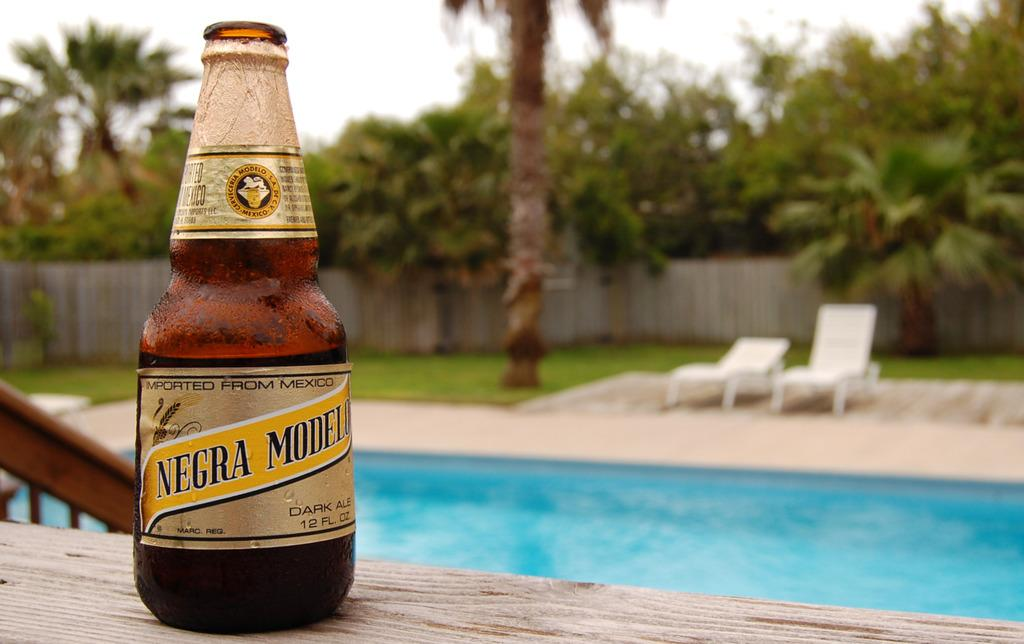<image>
Write a terse but informative summary of the picture. A bottle of Negra Modelo beer placed on a poolside. 